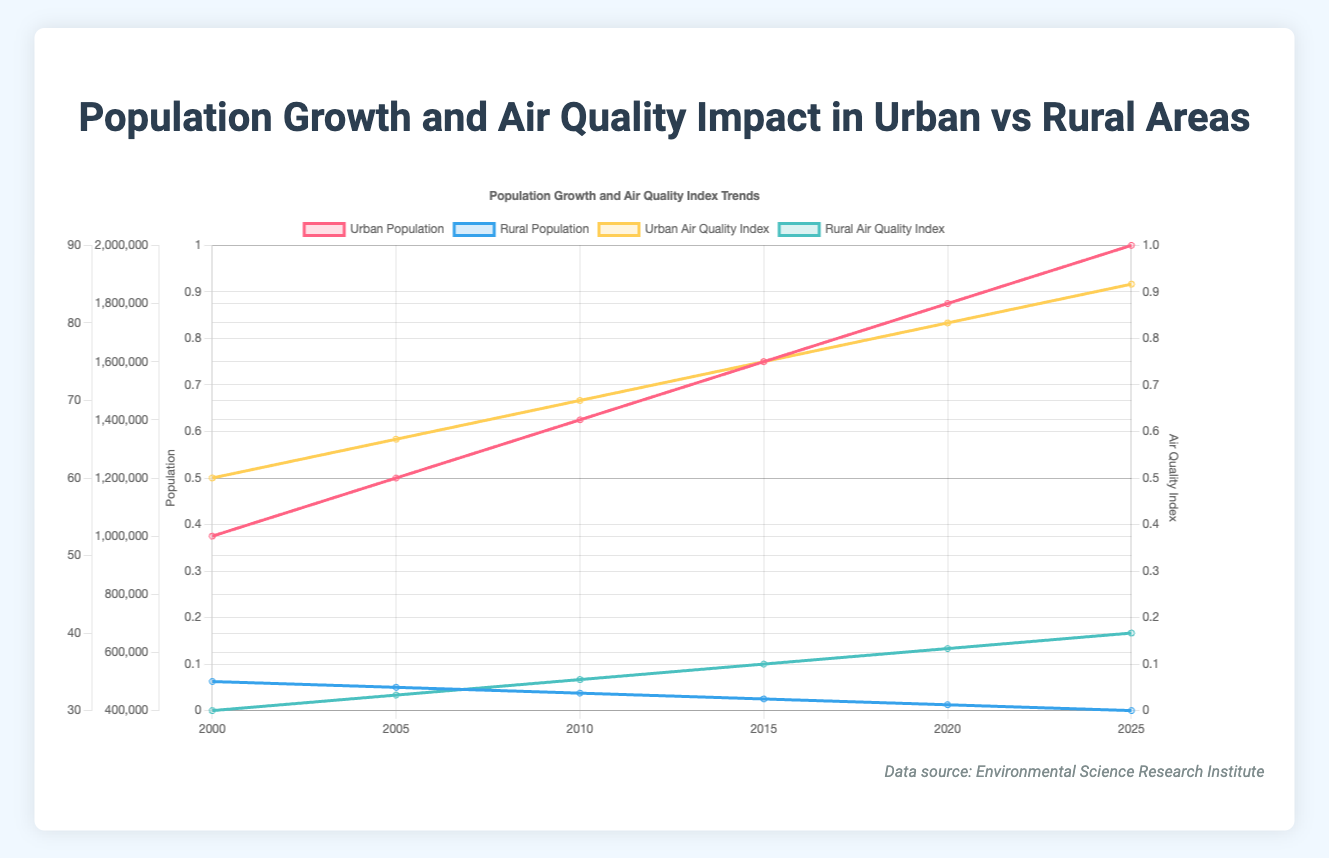What's the difference in Urban and Rural Populations in 2025? In 2025, the Urban Population is 2,000,000 and the Rural Population is 400,000. Subtracting the Rural Population from the Urban Population, we get 2,000,000 - 400,000 = 1,600,000.
Answer: 1,600,000 How has the Urban Air Quality Index changed from 2000 to 2025? The Urban Air Quality Index in 2000 was 60, and in 2025 it is 85. The change is 85 - 60 = 25.
Answer: 25 In which year is the Rural Air Quality Index equal to 36? The Rural Air Quality Index equals 36 in the year 2015, as seen from the plot showing the data points for each year.
Answer: 2015 What's the average Urban Population over the years 2000, 2005, and 2010? The Urban Populations in 2000, 2005, and 2010 are 1,000,000, 1,200,000, and 1,400,000 respectively. Summing these values gives 1,000,000 + 1,200,000 + 1,400,000 = 3,600,000. The average is 3,600,000 / 3 = 1,200,000.
Answer: 1,200,000 Compare the trend of Urban and Rural Populations from 2000 to 2025. From 2000 to 2025, the Urban Population shows a steady increase, going from 1,000,000 to 2,000,000. In contrast, the Rural Population consistently declines from 500,000 to 400,000 in the same period.
Answer: Urban Population increases, Rural Population decreases Which year experienced the highest Urban Air Quality Index and what was its value? The highest Urban Air Quality Index is observed in 2025 with a value of 85. This is determined by identifying the peak value in the Urban Air Quality Index data over the years.
Answer: 2025, 85 Is there any correlation between the Urban Population and the Urban Air Quality Index over the years? As the Urban Population increases from 1,000,000 to 2,000,000 within the given years, the Urban Air Quality Index also increases from 60 to 85, indicating a positive correlation between these two variables.
Answer: Positive correlation What is the total increase in the Rural Air Quality Index from 2000 to 2025? The Rural Air Quality Index increases from 30 in 2000 to 40 in 2025. The total increase is 40 - 30 = 10.
Answer: 10 Based on the plot, does the Urban or Rural area have a higher Air Quality Index in 2020? In 2020, the Urban Air Quality Index is 80 and the Rural Air Quality Index is 38. Therefore, the Urban area has a higher Air Quality Index.
Answer: Urban area Is the decline in Rural Population consistent across all the years shown in the plot? Yes, the Rural Population decreases consistently every 5 years from 500,000 in 2000 to 400,000 in 2025 by about 20,000 in each interval.
Answer: Yes 